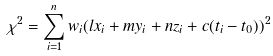Convert formula to latex. <formula><loc_0><loc_0><loc_500><loc_500>\chi ^ { 2 } = \sum _ { i = 1 } ^ { n } w _ { i } ( l x _ { i } + m y _ { i } + n z _ { i } + c ( t _ { i } - t _ { 0 } ) ) ^ { 2 }</formula> 